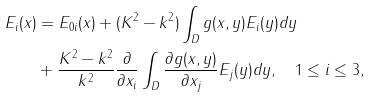Convert formula to latex. <formula><loc_0><loc_0><loc_500><loc_500>E _ { i } ( x ) & = E _ { 0 i } ( x ) + ( K ^ { 2 } - k ^ { 2 } ) \int _ { D } g ( x , y ) E _ { i } ( y ) d y \\ & + \frac { K ^ { 2 } - k ^ { 2 } } { k ^ { 2 } } \frac { \partial } { \partial x _ { i } } \int _ { D } \frac { \partial g ( x , y ) } { \partial x _ { j } } E _ { j } ( y ) d y , \quad 1 \leq i \leq 3 ,</formula> 